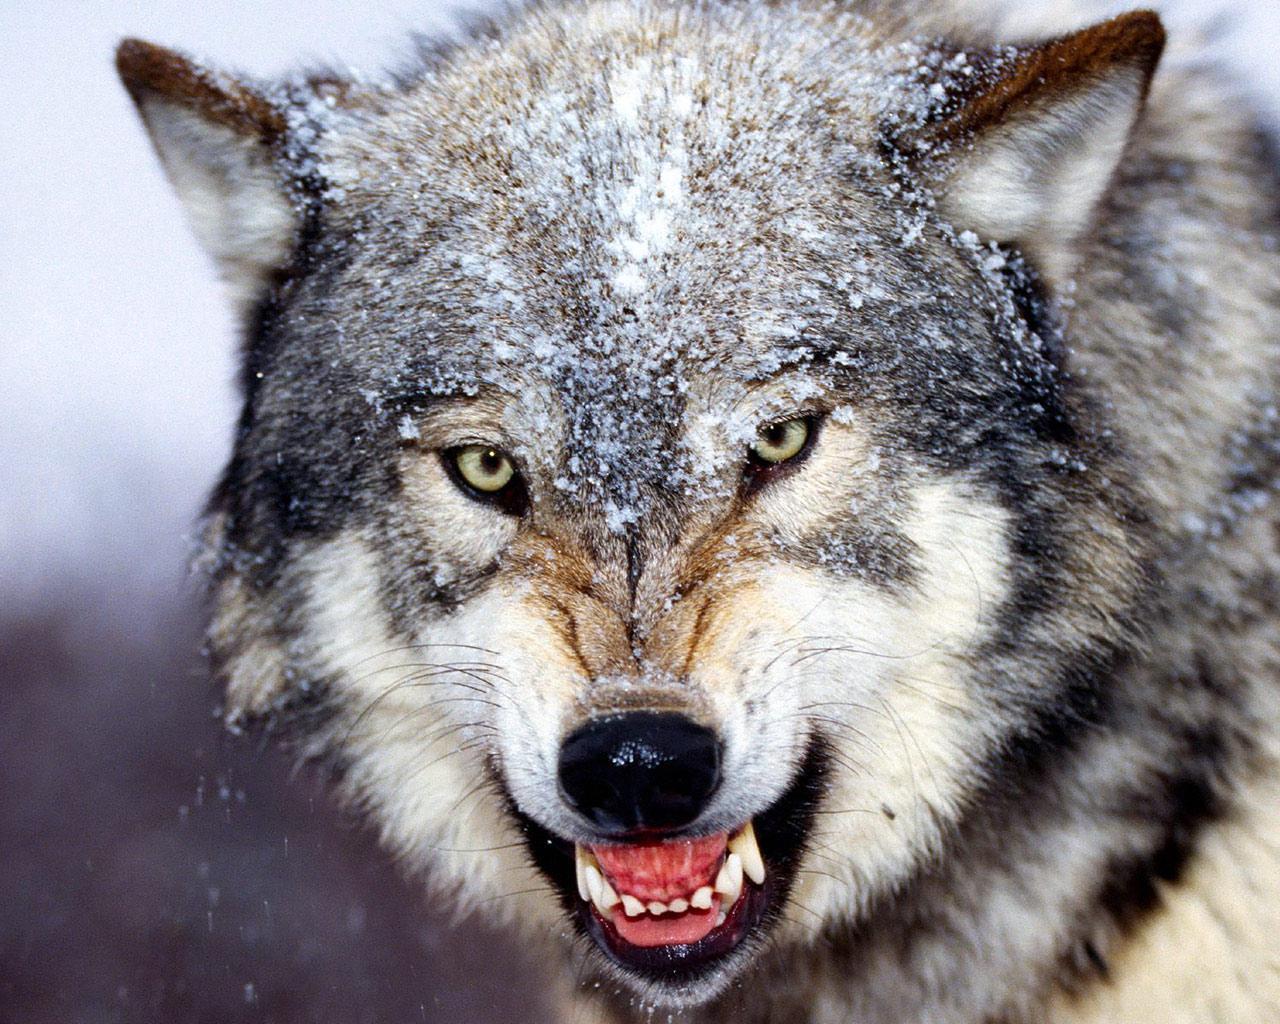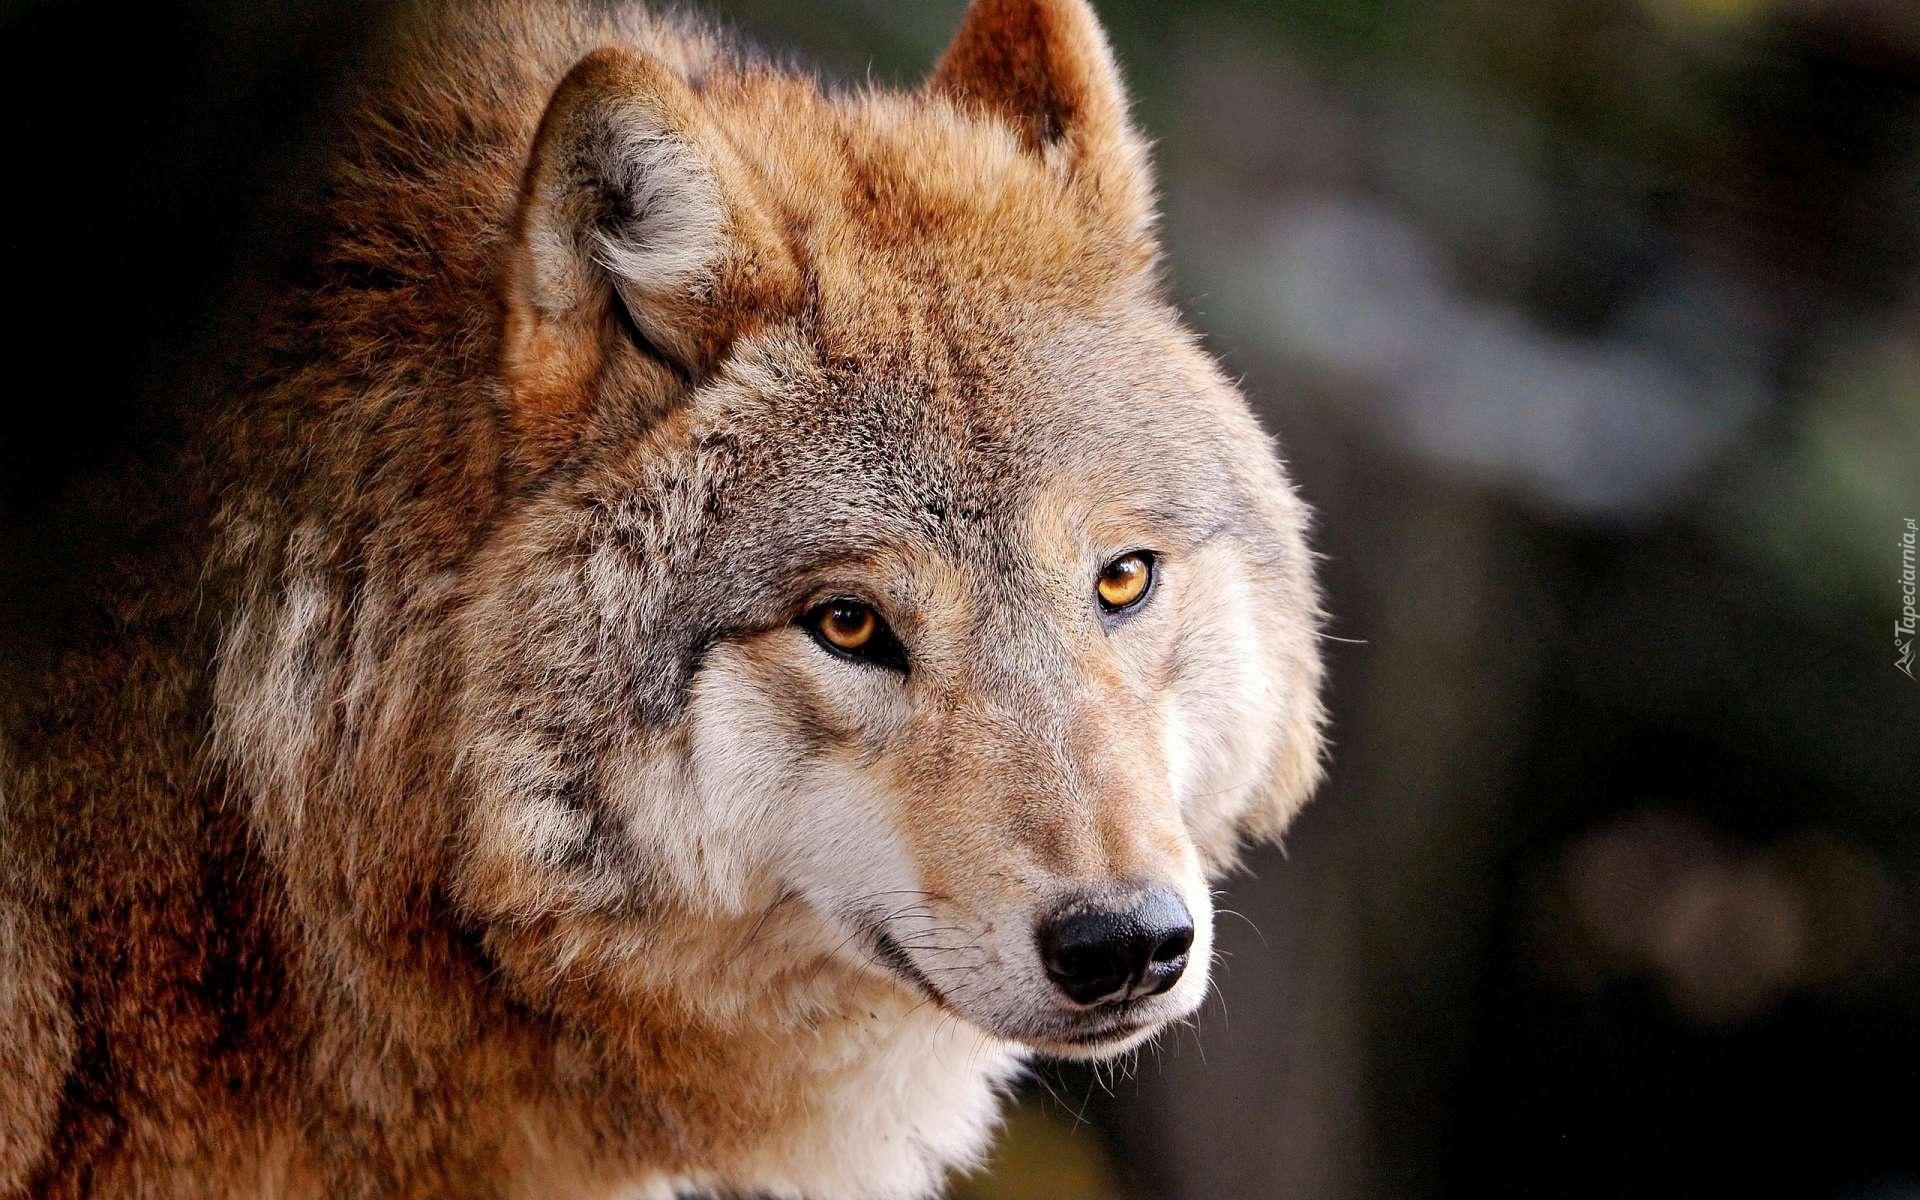The first image is the image on the left, the second image is the image on the right. For the images displayed, is the sentence "In one of the images, there is a wolf that is running." factually correct? Answer yes or no. No. The first image is the image on the left, the second image is the image on the right. For the images displayed, is the sentence "The combined images include two wolves in running poses." factually correct? Answer yes or no. No. 